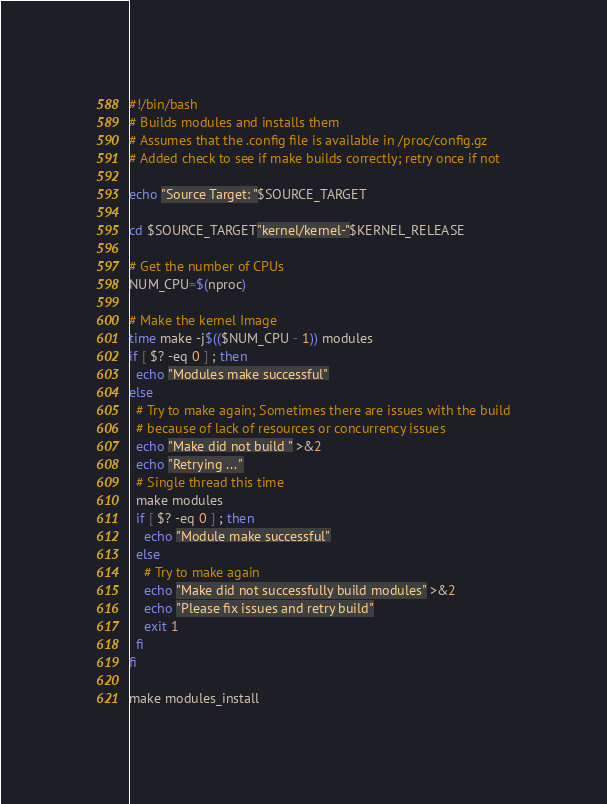<code> <loc_0><loc_0><loc_500><loc_500><_Bash_>#!/bin/bash
# Builds modules and installs them
# Assumes that the .config file is available in /proc/config.gz
# Added check to see if make builds correctly; retry once if not

echo "Source Target: "$SOURCE_TARGET

cd $SOURCE_TARGET"kernel/kernel-"$KERNEL_RELEASE

# Get the number of CPUs 
NUM_CPU=$(nproc)

# Make the kernel Image 
time make -j$(($NUM_CPU - 1)) modules
if [ $? -eq 0 ] ; then
  echo "Modules make successful"
else
  # Try to make again; Sometimes there are issues with the build
  # because of lack of resources or concurrency issues
  echo "Make did not build " >&2
  echo "Retrying ... "
  # Single thread this time
  make modules
  if [ $? -eq 0 ] ; then
    echo "Module make successful"
  else
    # Try to make again
    echo "Make did not successfully build modules" >&2
    echo "Please fix issues and retry build"
    exit 1
  fi
fi

make modules_install


</code> 